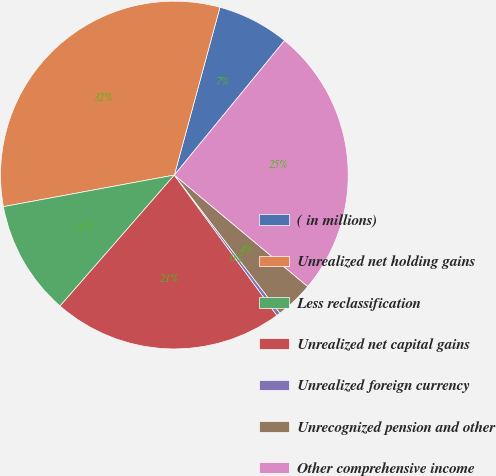Convert chart. <chart><loc_0><loc_0><loc_500><loc_500><pie_chart><fcel>( in millions)<fcel>Unrealized net holding gains<fcel>Less reclassification<fcel>Unrealized net capital gains<fcel>Unrealized foreign currency<fcel>Unrecognized pension and other<fcel>Other comprehensive income<nl><fcel>6.7%<fcel>32.13%<fcel>10.67%<fcel>21.46%<fcel>0.35%<fcel>3.53%<fcel>25.16%<nl></chart> 